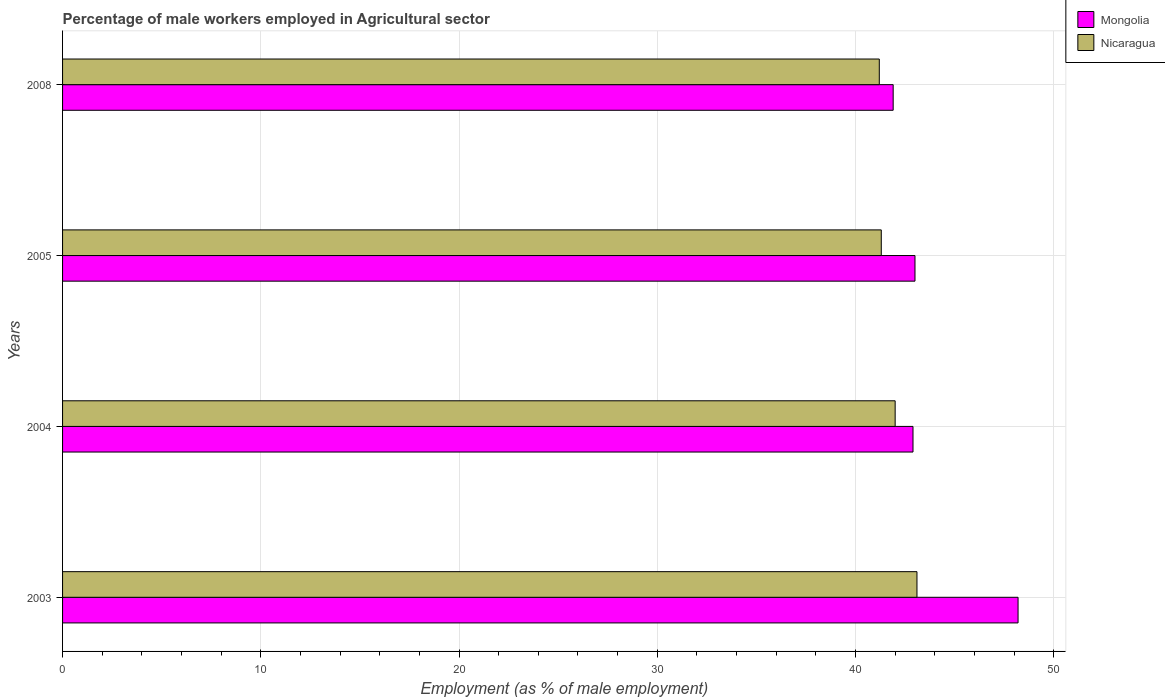What is the label of the 2nd group of bars from the top?
Your answer should be very brief. 2005. In how many cases, is the number of bars for a given year not equal to the number of legend labels?
Provide a short and direct response. 0. What is the percentage of male workers employed in Agricultural sector in Nicaragua in 2003?
Offer a very short reply. 43.1. Across all years, what is the maximum percentage of male workers employed in Agricultural sector in Nicaragua?
Provide a short and direct response. 43.1. Across all years, what is the minimum percentage of male workers employed in Agricultural sector in Nicaragua?
Offer a terse response. 41.2. In which year was the percentage of male workers employed in Agricultural sector in Nicaragua minimum?
Give a very brief answer. 2008. What is the total percentage of male workers employed in Agricultural sector in Nicaragua in the graph?
Provide a short and direct response. 167.6. What is the difference between the percentage of male workers employed in Agricultural sector in Mongolia in 2004 and that in 2008?
Your answer should be very brief. 1. What is the difference between the percentage of male workers employed in Agricultural sector in Mongolia in 2008 and the percentage of male workers employed in Agricultural sector in Nicaragua in 2003?
Your response must be concise. -1.2. What is the average percentage of male workers employed in Agricultural sector in Nicaragua per year?
Keep it short and to the point. 41.9. In the year 2008, what is the difference between the percentage of male workers employed in Agricultural sector in Nicaragua and percentage of male workers employed in Agricultural sector in Mongolia?
Your response must be concise. -0.7. What is the ratio of the percentage of male workers employed in Agricultural sector in Nicaragua in 2003 to that in 2004?
Provide a short and direct response. 1.03. Is the percentage of male workers employed in Agricultural sector in Mongolia in 2003 less than that in 2004?
Your answer should be compact. No. Is the difference between the percentage of male workers employed in Agricultural sector in Nicaragua in 2003 and 2005 greater than the difference between the percentage of male workers employed in Agricultural sector in Mongolia in 2003 and 2005?
Make the answer very short. No. What is the difference between the highest and the second highest percentage of male workers employed in Agricultural sector in Nicaragua?
Offer a very short reply. 1.1. What is the difference between the highest and the lowest percentage of male workers employed in Agricultural sector in Nicaragua?
Your answer should be compact. 1.9. In how many years, is the percentage of male workers employed in Agricultural sector in Mongolia greater than the average percentage of male workers employed in Agricultural sector in Mongolia taken over all years?
Ensure brevity in your answer.  1. What does the 2nd bar from the top in 2004 represents?
Provide a short and direct response. Mongolia. What does the 2nd bar from the bottom in 2005 represents?
Your answer should be compact. Nicaragua. How many bars are there?
Your response must be concise. 8. Are the values on the major ticks of X-axis written in scientific E-notation?
Make the answer very short. No. Does the graph contain any zero values?
Provide a short and direct response. No. Does the graph contain grids?
Provide a succinct answer. Yes. How many legend labels are there?
Offer a terse response. 2. What is the title of the graph?
Provide a short and direct response. Percentage of male workers employed in Agricultural sector. What is the label or title of the X-axis?
Your answer should be compact. Employment (as % of male employment). What is the Employment (as % of male employment) in Mongolia in 2003?
Provide a succinct answer. 48.2. What is the Employment (as % of male employment) of Nicaragua in 2003?
Keep it short and to the point. 43.1. What is the Employment (as % of male employment) of Mongolia in 2004?
Your answer should be compact. 42.9. What is the Employment (as % of male employment) of Nicaragua in 2004?
Your answer should be compact. 42. What is the Employment (as % of male employment) in Nicaragua in 2005?
Ensure brevity in your answer.  41.3. What is the Employment (as % of male employment) of Mongolia in 2008?
Your answer should be compact. 41.9. What is the Employment (as % of male employment) in Nicaragua in 2008?
Keep it short and to the point. 41.2. Across all years, what is the maximum Employment (as % of male employment) of Mongolia?
Offer a terse response. 48.2. Across all years, what is the maximum Employment (as % of male employment) of Nicaragua?
Ensure brevity in your answer.  43.1. Across all years, what is the minimum Employment (as % of male employment) of Mongolia?
Your response must be concise. 41.9. Across all years, what is the minimum Employment (as % of male employment) of Nicaragua?
Ensure brevity in your answer.  41.2. What is the total Employment (as % of male employment) of Mongolia in the graph?
Offer a very short reply. 176. What is the total Employment (as % of male employment) in Nicaragua in the graph?
Your answer should be compact. 167.6. What is the difference between the Employment (as % of male employment) of Mongolia in 2003 and that in 2004?
Your response must be concise. 5.3. What is the difference between the Employment (as % of male employment) in Nicaragua in 2003 and that in 2008?
Give a very brief answer. 1.9. What is the difference between the Employment (as % of male employment) in Mongolia in 2004 and that in 2005?
Offer a terse response. -0.1. What is the difference between the Employment (as % of male employment) of Nicaragua in 2004 and that in 2005?
Give a very brief answer. 0.7. What is the difference between the Employment (as % of male employment) of Mongolia in 2004 and that in 2008?
Provide a succinct answer. 1. What is the difference between the Employment (as % of male employment) in Mongolia in 2005 and that in 2008?
Your answer should be very brief. 1.1. What is the difference between the Employment (as % of male employment) in Nicaragua in 2005 and that in 2008?
Provide a succinct answer. 0.1. What is the difference between the Employment (as % of male employment) of Mongolia in 2003 and the Employment (as % of male employment) of Nicaragua in 2004?
Make the answer very short. 6.2. What is the difference between the Employment (as % of male employment) of Mongolia in 2003 and the Employment (as % of male employment) of Nicaragua in 2005?
Provide a short and direct response. 6.9. What is the difference between the Employment (as % of male employment) of Mongolia in 2003 and the Employment (as % of male employment) of Nicaragua in 2008?
Make the answer very short. 7. What is the difference between the Employment (as % of male employment) in Mongolia in 2004 and the Employment (as % of male employment) in Nicaragua in 2005?
Ensure brevity in your answer.  1.6. What is the difference between the Employment (as % of male employment) in Mongolia in 2004 and the Employment (as % of male employment) in Nicaragua in 2008?
Ensure brevity in your answer.  1.7. What is the average Employment (as % of male employment) in Nicaragua per year?
Provide a short and direct response. 41.9. In the year 2003, what is the difference between the Employment (as % of male employment) in Mongolia and Employment (as % of male employment) in Nicaragua?
Your answer should be very brief. 5.1. What is the ratio of the Employment (as % of male employment) of Mongolia in 2003 to that in 2004?
Offer a terse response. 1.12. What is the ratio of the Employment (as % of male employment) of Nicaragua in 2003 to that in 2004?
Your response must be concise. 1.03. What is the ratio of the Employment (as % of male employment) in Mongolia in 2003 to that in 2005?
Your response must be concise. 1.12. What is the ratio of the Employment (as % of male employment) of Nicaragua in 2003 to that in 2005?
Ensure brevity in your answer.  1.04. What is the ratio of the Employment (as % of male employment) in Mongolia in 2003 to that in 2008?
Give a very brief answer. 1.15. What is the ratio of the Employment (as % of male employment) of Nicaragua in 2003 to that in 2008?
Provide a succinct answer. 1.05. What is the ratio of the Employment (as % of male employment) of Nicaragua in 2004 to that in 2005?
Give a very brief answer. 1.02. What is the ratio of the Employment (as % of male employment) in Mongolia in 2004 to that in 2008?
Ensure brevity in your answer.  1.02. What is the ratio of the Employment (as % of male employment) in Nicaragua in 2004 to that in 2008?
Provide a succinct answer. 1.02. What is the ratio of the Employment (as % of male employment) in Mongolia in 2005 to that in 2008?
Offer a terse response. 1.03. What is the ratio of the Employment (as % of male employment) of Nicaragua in 2005 to that in 2008?
Offer a terse response. 1. What is the difference between the highest and the second highest Employment (as % of male employment) in Mongolia?
Make the answer very short. 5.2. What is the difference between the highest and the second highest Employment (as % of male employment) in Nicaragua?
Provide a short and direct response. 1.1. What is the difference between the highest and the lowest Employment (as % of male employment) in Nicaragua?
Offer a terse response. 1.9. 